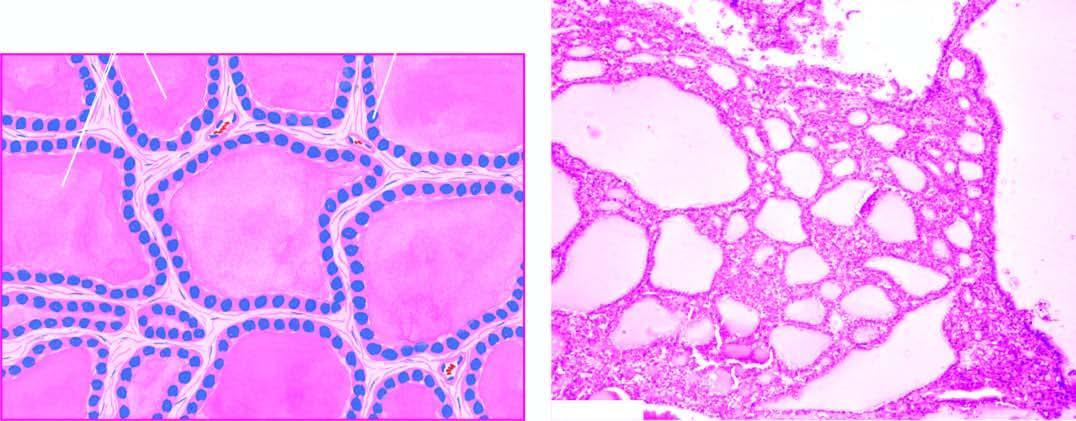what shows large follicles distended by colloid and lined by flattened follicular epithelium?
Answer the question using a single word or phrase. Microscopy 